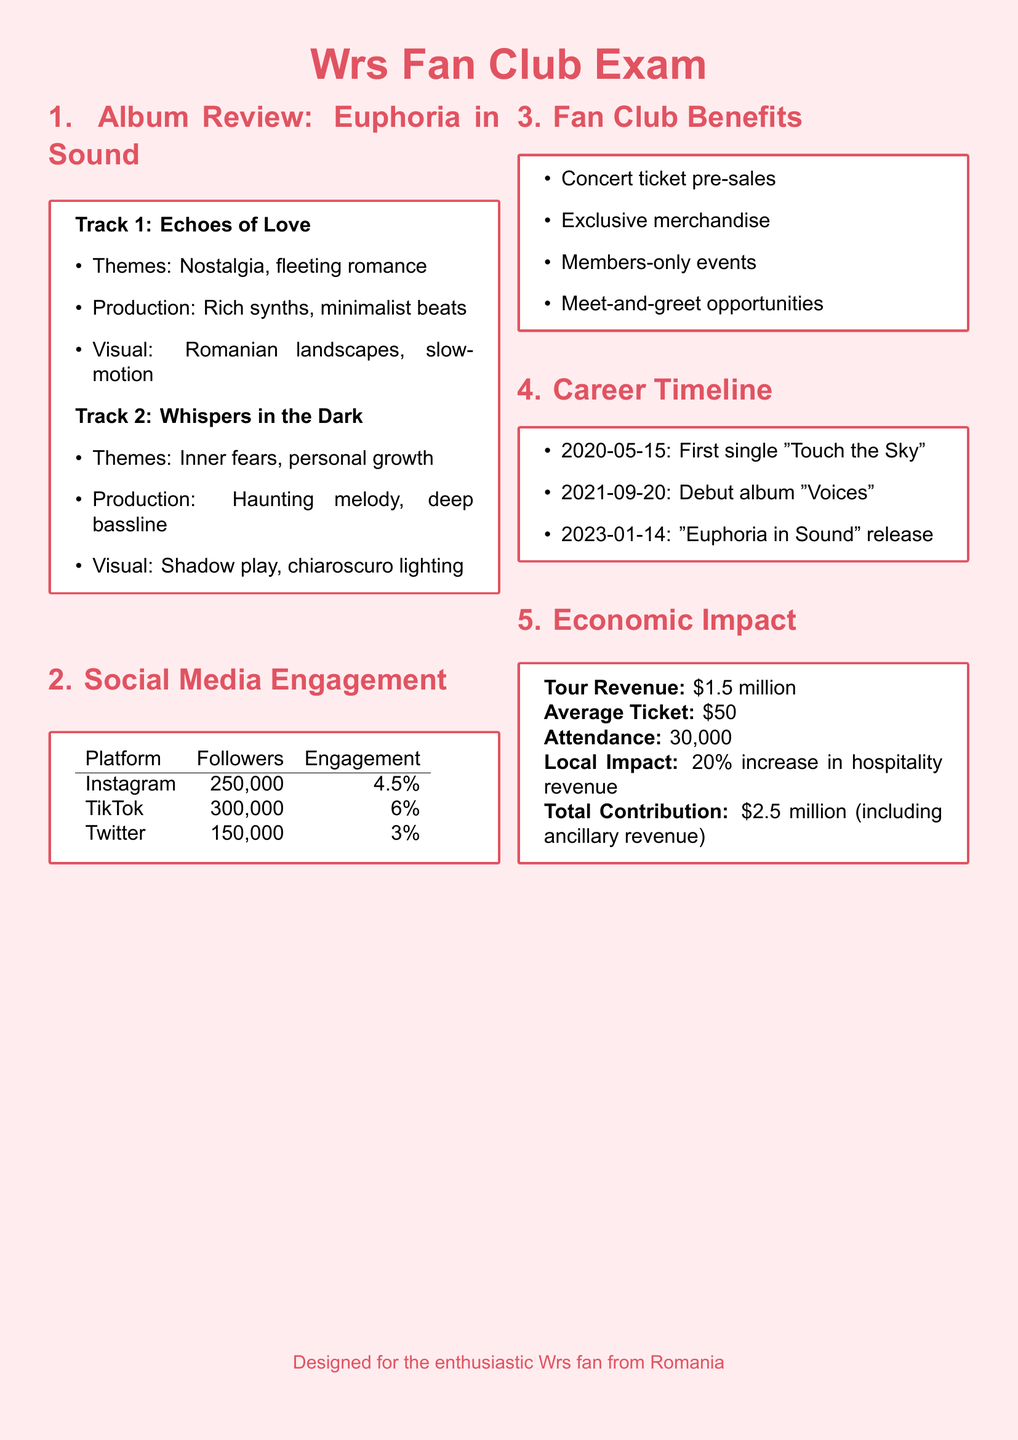What is the release date of "Euphoria in Sound"? The release date is stated in the career timeline section of the document, which is 2023-01-14.
Answer: 2023-01-14 How many followers does Wrs have on TikTok? The number of followers on TikTok is listed in the social media engagement section of the document, which is 300,000.
Answer: 300,000 What are the themes of "Echoes of Love"? The document specifies the themes of "Echoes of Love" in the album review section as nostalgia and fleeting romance.
Answer: Nostalgia, fleeting romance What percentage increase in hospitality revenue is reported from Wrs' tours? The document provides the local impact of Wrs' tours, which states a 20% increase in hospitality revenue.
Answer: 20% What is the average ticket price for Wrs' concerts? The average ticket price is given in the economic impact section of the document, which is $50.
Answer: $50 What are two benefits of being a member of Wrs' fan club? The document lists several exclusive benefits for fan club members, two of which are concert ticket pre-sales and exclusive merchandise.
Answer: Concert ticket pre-sales, exclusive merchandise What was the first single released by Wrs? The career timeline in the document indicates that the first single released was "Touch the Sky."
Answer: Touch the Sky What is the engagement percentage for Wrs on Instagram? This information can be found in the social media engagement section, which states an engagement of 4.5%.
Answer: 4.5% How many members-only events does Wrs offer? The document mentions “members-only events” as part of the fan club benefits without stating a specific number.
Answer: 1 (Members-only events) 